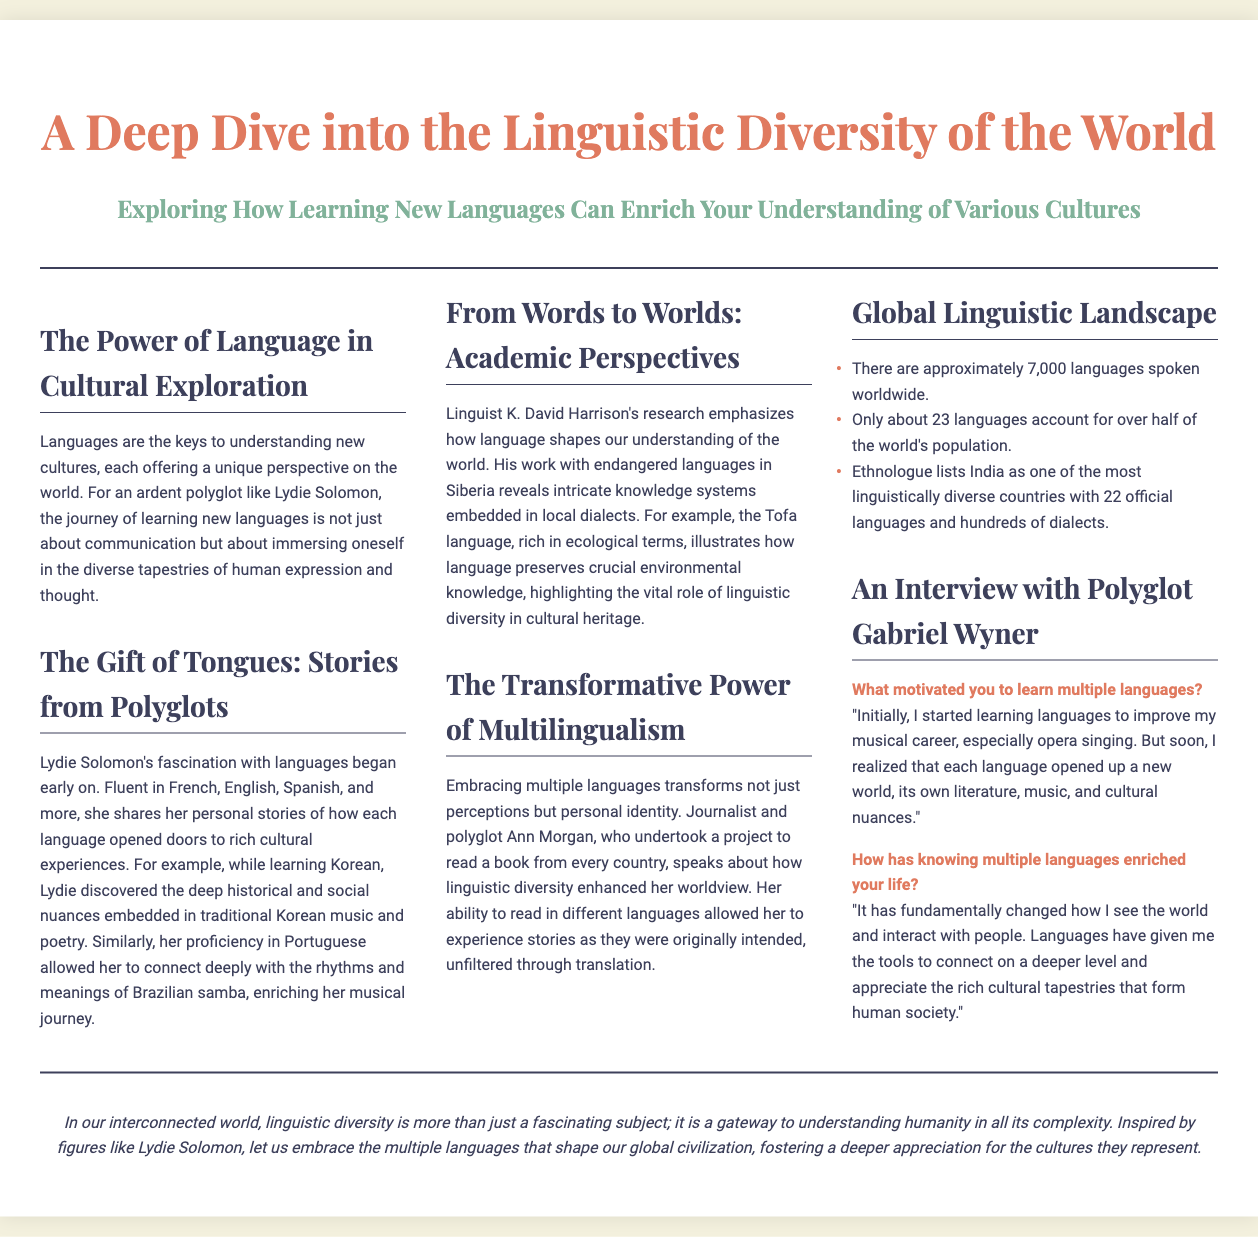What is the title of the document? The title is the main heading of the document, which is clearly stated at the top.
Answer: A Deep Dive into the Linguistic Diversity of the World Who is the prominent polyglot mentioned in the document? The document specifically highlights the experiences and stories of a notable polyglot.
Answer: Lydie Solomon How many languages are approximately spoken worldwide? This number is mentioned in the section about the global linguistic landscape.
Answer: 7,000 What is the profession of Ann Morgan? The document describes her involvement in a specific type of work related to languages and literature.
Answer: Journalist What motivated Gabriel Wyner to learn multiple languages? His initial reason for learning languages is directly quoted in the interview section.
Answer: Musical career Which language helped Lydie Solomon connect with Brazilian samba? The document provides details on how specific languages impacted her cultural experiences.
Answer: Portuguese What aspect of language does K. David Harrison's research highlight? The document emphasizes a particular theme investigated in his linguistic research.
Answer: Ecological terms How many official languages does India have? This information is stated in the statistics section discussing linguistic diversity.
Answer: 22 